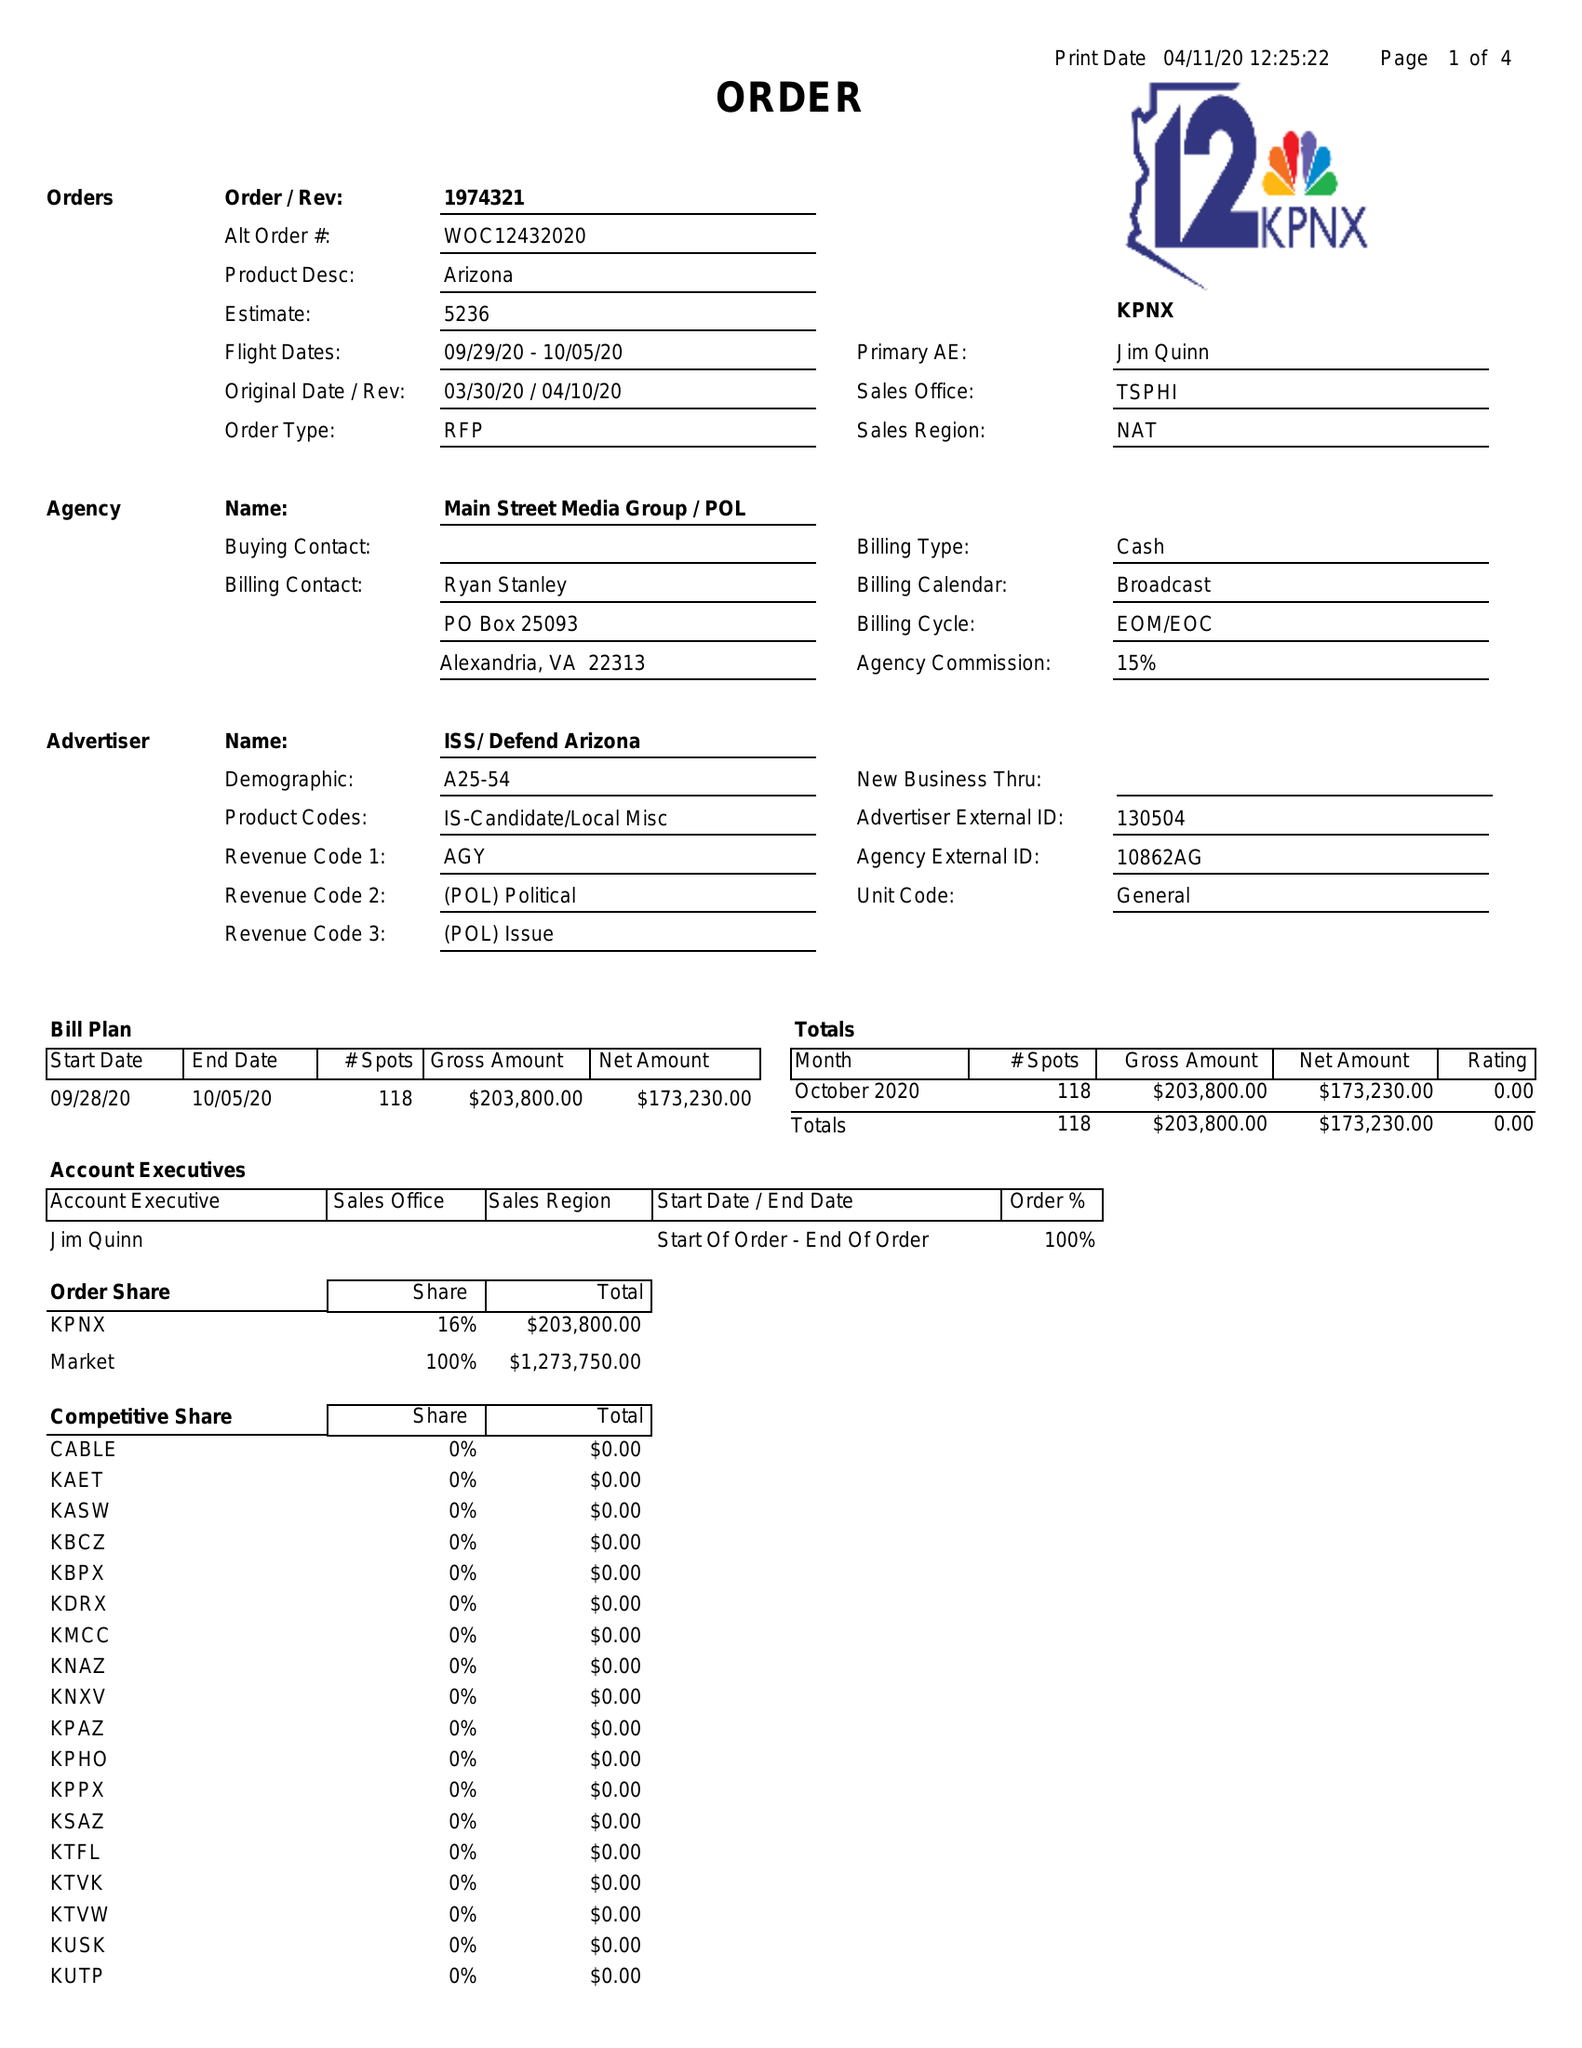What is the value for the flight_from?
Answer the question using a single word or phrase. 09/29/20 